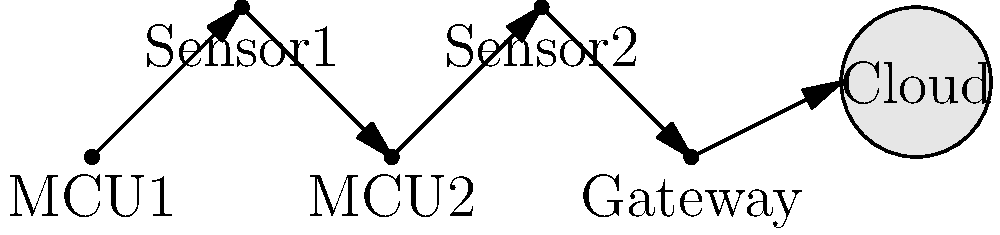In the IoT system shown above, which uses microcontrollers (MCUs) to collect data from sensors and transmit it to a cloud platform, what network topology is being implemented, and how many hops does the data from Sensor1 take to reach the cloud? To answer this question, let's analyze the network topology and data flow step by step:

1. Network Topology:
   - The devices are connected in a linear fashion, with each device connected to the next in sequence.
   - This arrangement forms a daisy chain or linear bus topology.

2. Data Flow:
   - Sensor1 is connected to MCU1
   - MCU1 is connected to MCU2
   - MCU2 is connected to Sensor2
   - Sensor2 is connected to the Gateway
   - The Gateway is connected to the Cloud

3. Counting hops from Sensor1 to the Cloud:
   - Hop 1: Sensor1 to MCU1
   - Hop 2: MCU1 to MCU2
   - Hop 3: MCU2 to Sensor2
   - Hop 4: Sensor2 to Gateway
   - Hop 5: Gateway to Cloud

Therefore, the network topology is a daisy chain or linear bus, and the data from Sensor1 takes 5 hops to reach the cloud.
Answer: Daisy chain topology; 5 hops 